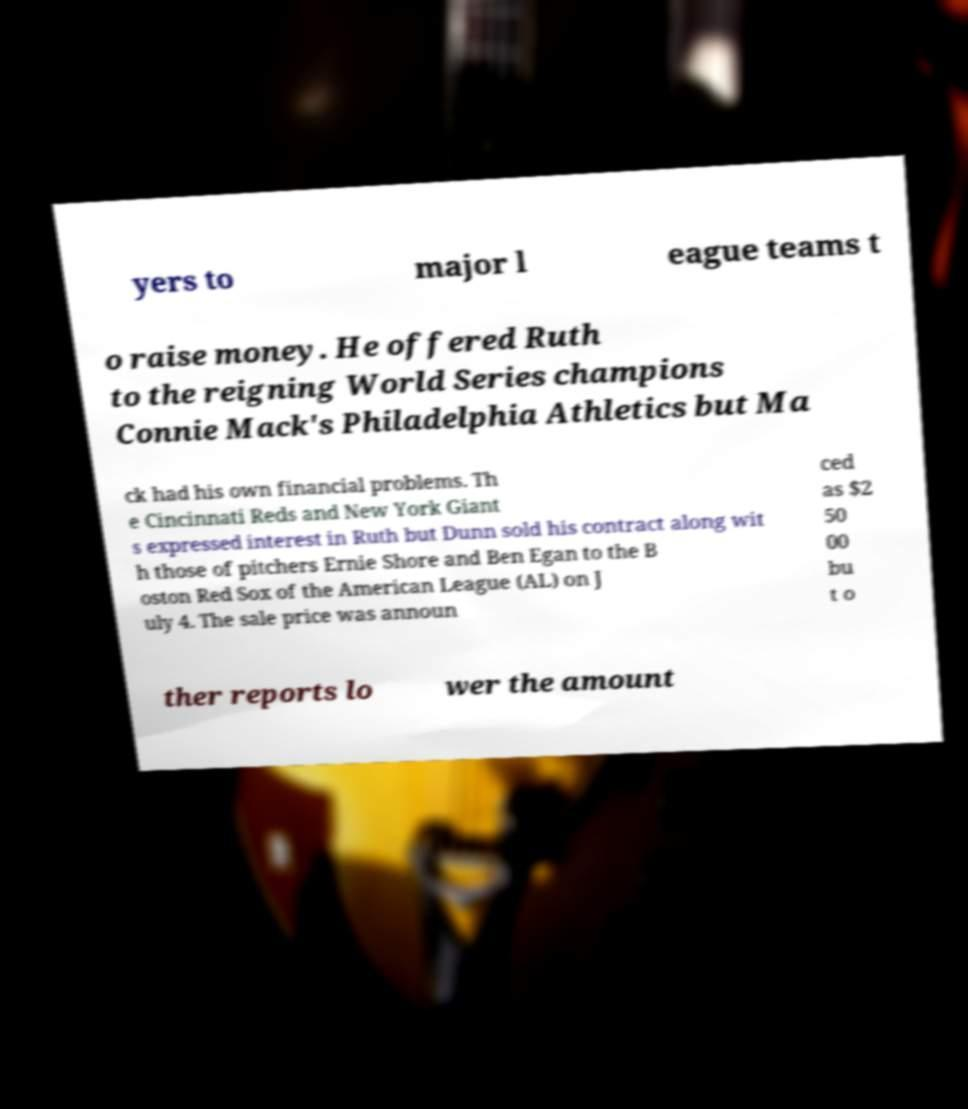What messages or text are displayed in this image? I need them in a readable, typed format. yers to major l eague teams t o raise money. He offered Ruth to the reigning World Series champions Connie Mack's Philadelphia Athletics but Ma ck had his own financial problems. Th e Cincinnati Reds and New York Giant s expressed interest in Ruth but Dunn sold his contract along wit h those of pitchers Ernie Shore and Ben Egan to the B oston Red Sox of the American League (AL) on J uly 4. The sale price was announ ced as $2 50 00 bu t o ther reports lo wer the amount 